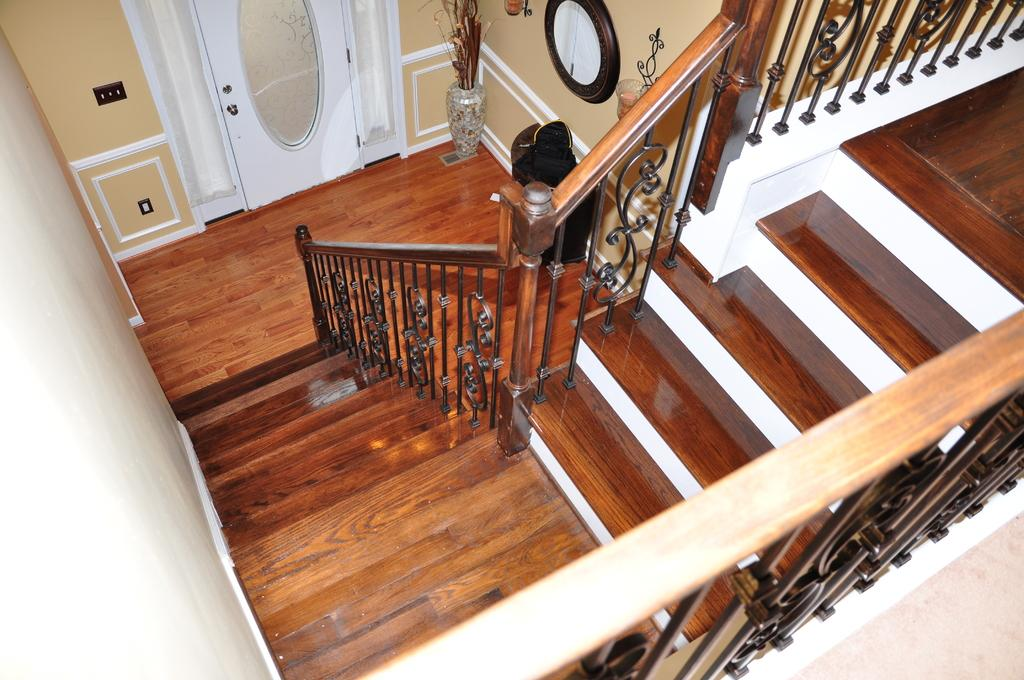What architectural feature can be seen in the image? There are steps in the image. What is used to enclose or separate areas in the image? There is a fence in the image. What can be used to enter or exit a space in the image? There is a door in the image. What surface is visible underfoot in the image? There is a floor in the image. What type of decorative item is present in the image? There is a flower pot in the image. What objects provide illumination in the image? There are lamps in the image. What type of background can be seen in the image? There is a wall visible in the background of the image. Can you tell me how many giraffes are visible in the image? There are no giraffes present in the image. What type of insect can be seen crawling on the wall in the image? There are no insects visible in the image. 